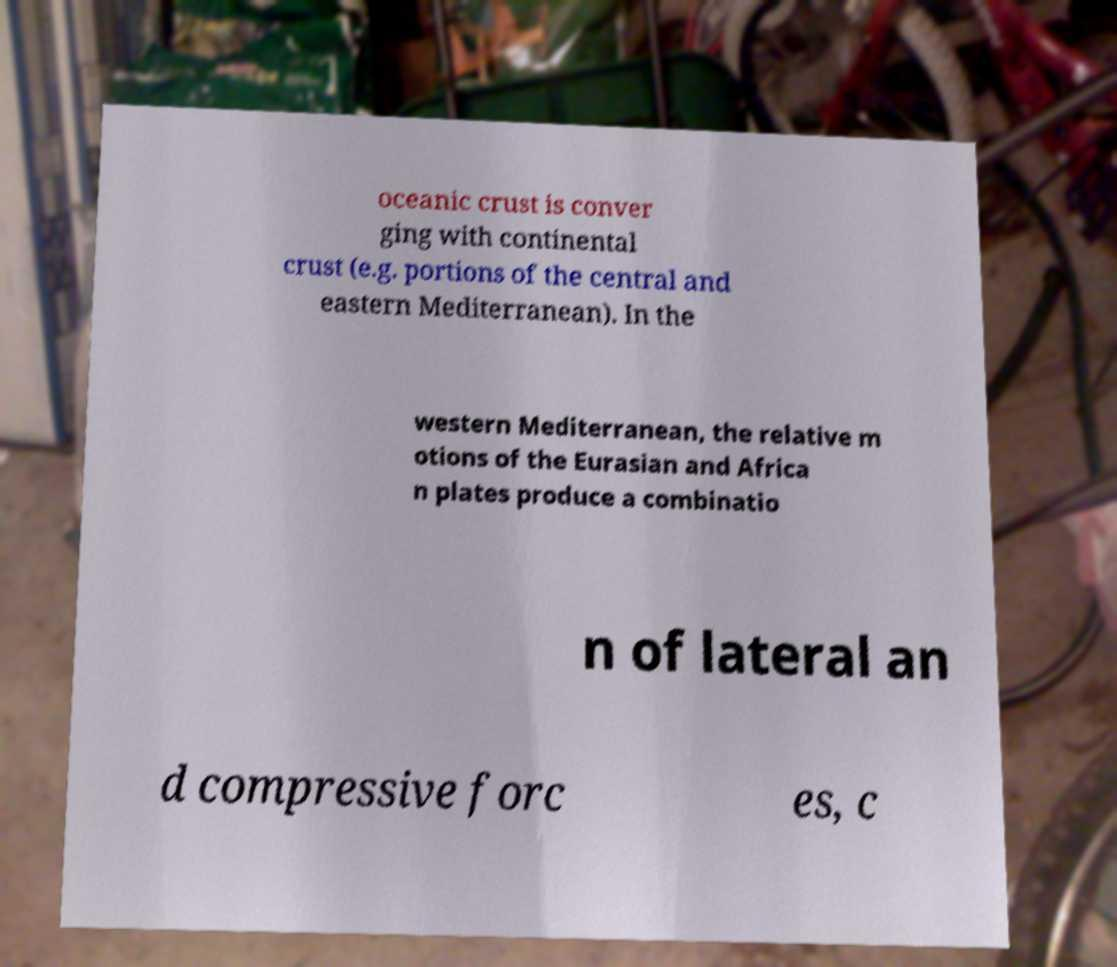Could you assist in decoding the text presented in this image and type it out clearly? oceanic crust is conver ging with continental crust (e.g. portions of the central and eastern Mediterranean). In the western Mediterranean, the relative m otions of the Eurasian and Africa n plates produce a combinatio n of lateral an d compressive forc es, c 